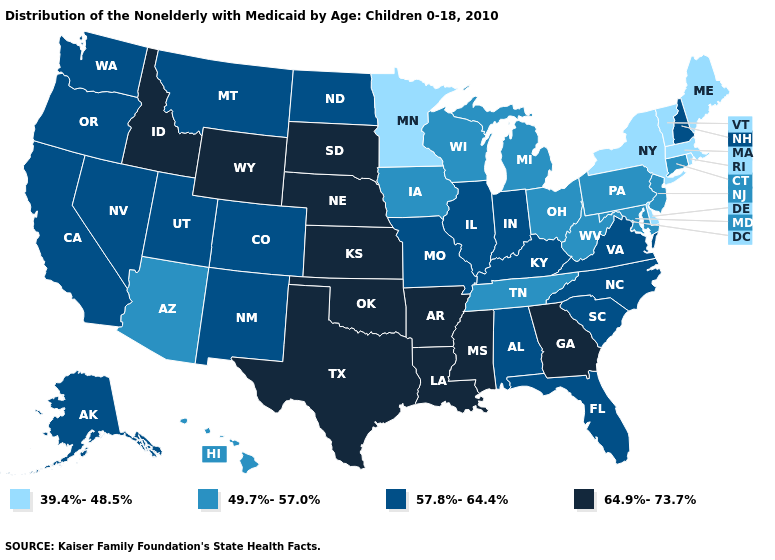What is the value of Maryland?
Keep it brief. 49.7%-57.0%. How many symbols are there in the legend?
Be succinct. 4. What is the value of Georgia?
Keep it brief. 64.9%-73.7%. What is the value of New Hampshire?
Quick response, please. 57.8%-64.4%. What is the value of New York?
Concise answer only. 39.4%-48.5%. Name the states that have a value in the range 39.4%-48.5%?
Give a very brief answer. Delaware, Maine, Massachusetts, Minnesota, New York, Rhode Island, Vermont. Among the states that border New Mexico , does Texas have the highest value?
Be succinct. Yes. What is the highest value in the West ?
Quick response, please. 64.9%-73.7%. Which states have the lowest value in the Northeast?
Quick response, please. Maine, Massachusetts, New York, Rhode Island, Vermont. What is the value of Alabama?
Write a very short answer. 57.8%-64.4%. Does Tennessee have the highest value in the USA?
Quick response, please. No. Does Texas have the highest value in the South?
Write a very short answer. Yes. What is the value of Georgia?
Short answer required. 64.9%-73.7%. Does Ohio have the highest value in the MidWest?
Give a very brief answer. No. Does Vermont have a lower value than North Carolina?
Be succinct. Yes. 